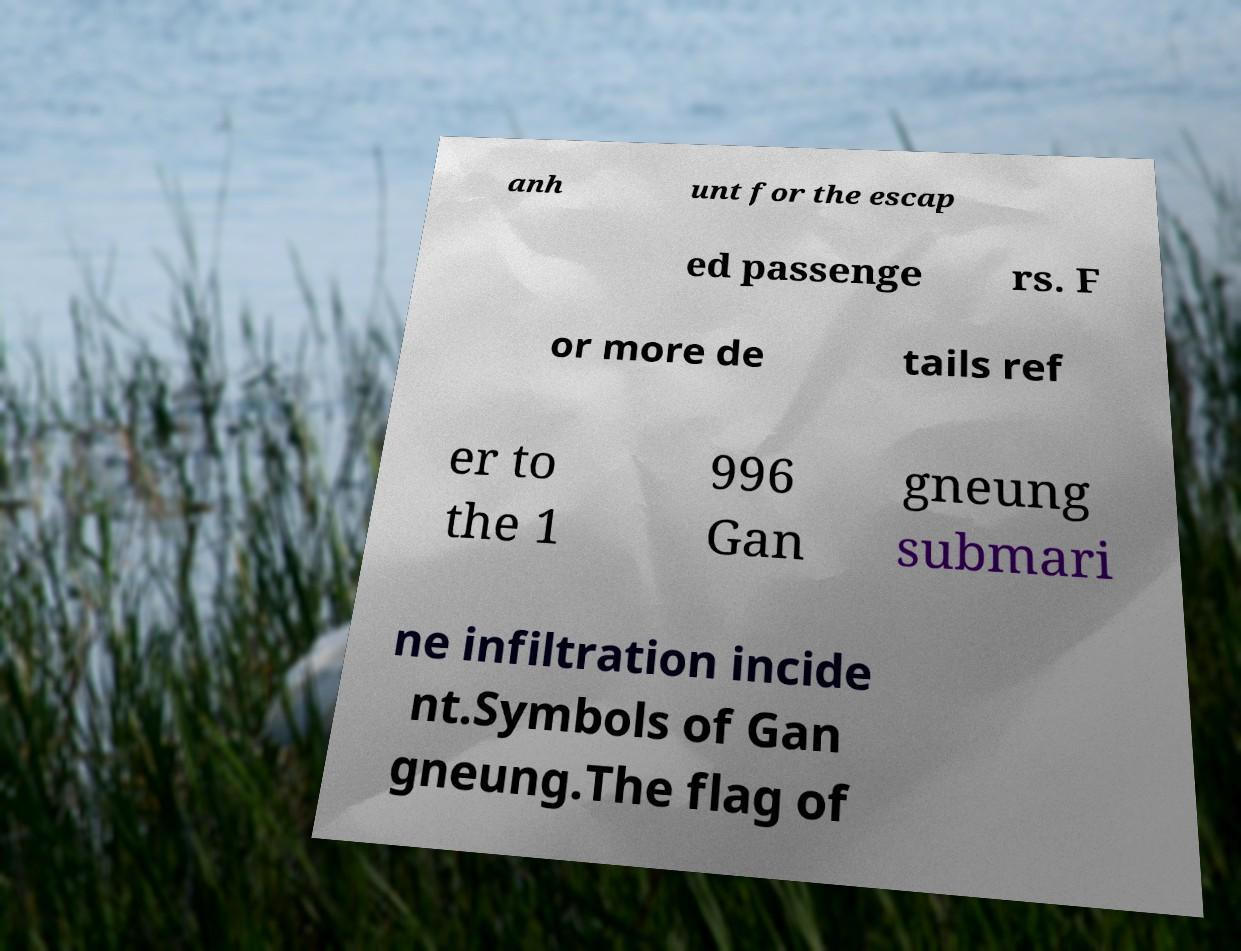Could you assist in decoding the text presented in this image and type it out clearly? anh unt for the escap ed passenge rs. F or more de tails ref er to the 1 996 Gan gneung submari ne infiltration incide nt.Symbols of Gan gneung.The flag of 